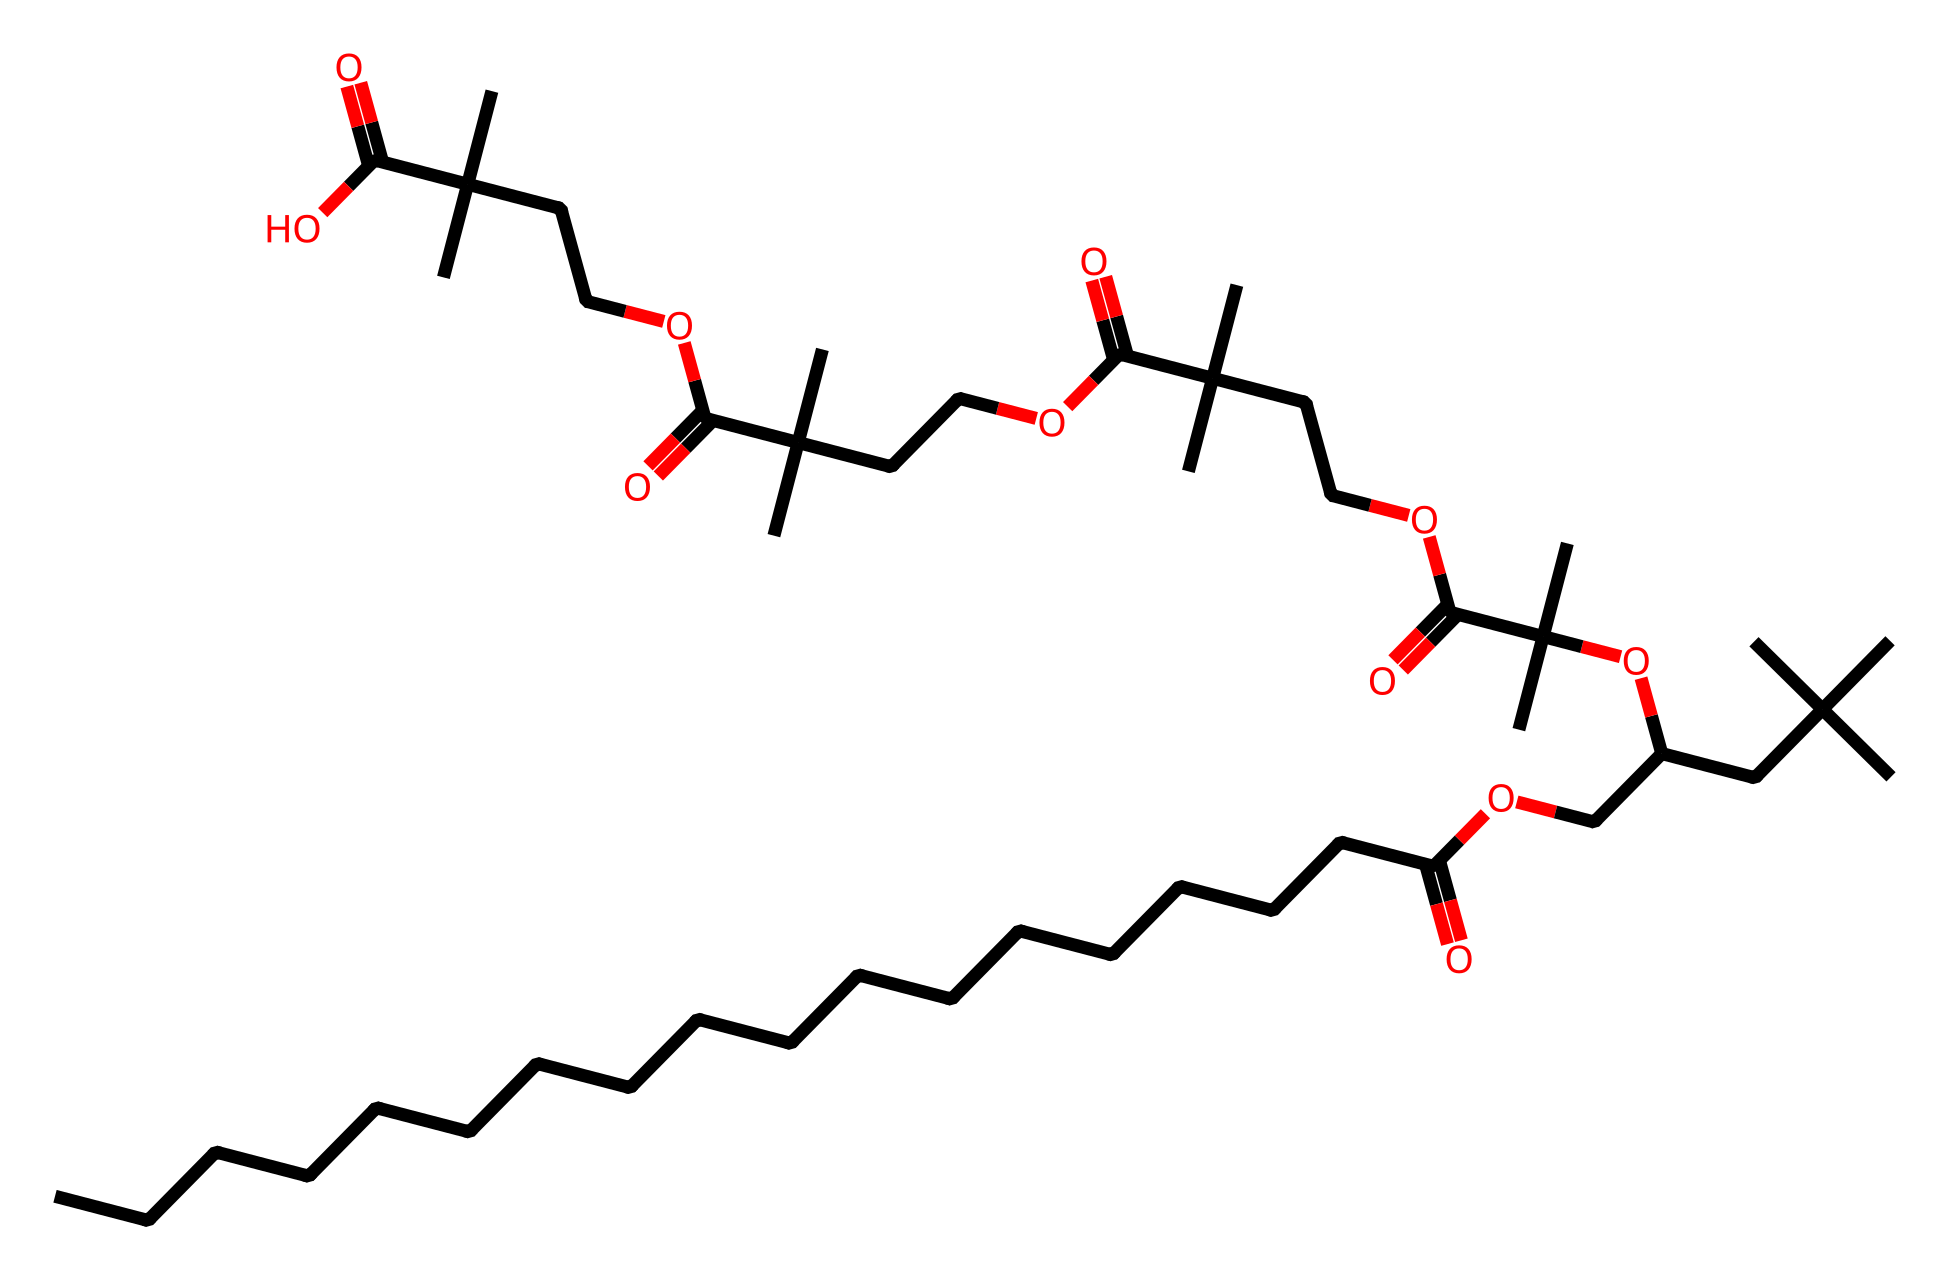What is the molecular formula for polysorbate 20? To derive the molecular formula from the SMILES representation, we count the types of atoms present in the structure. The repeated units indicate a significant number of carbon (C), hydrogen (H), and oxygen (O) atoms. The expected molecular formula for polysorbate 20 is C20H42O8.
Answer: C20H42O8 How many carbon atoms are in polysorbate 20? By analyzing the SMILES structure, the longest carbon chain and branching indicates a total count of 20 carbon atoms throughout the molecule.
Answer: 20 What functional groups are present in polysorbate 20? The structure reveals several functional groups including esters (due to the presence of ester linkages) and possibly hydroxyl groups at the ends, indicated by the carbon atoms connected to oxygen.
Answer: ester, hydroxyl Is polysorbate 20 anionic, cationic, or nonionic surfactant? The chemical structure lacks a charge and does not have any ionizable groups, which categorizes it as a nonionic surfactant.
Answer: nonionic What type of emulsifier is polysorbate 20 commonly used as? Polysorbate 20 is commonly employed as an emulsifying agent, which helps stabilize emulsions between water and oils.
Answer: emulsifier How many oxygen atoms are in polysorbate 20? From the molecular formula derived earlier, we can see that there are 8 oxygen atoms in polysorbate 20.
Answer: 8 What is the primary application of polysorbate 20 in cosmetics? Due to its emulsifying properties, polysorbate 20 is primarily used in cosmetics to help mix oil and water, providing a stable formulation in products like creams and liquid makeup.
Answer: emulsifying agent 